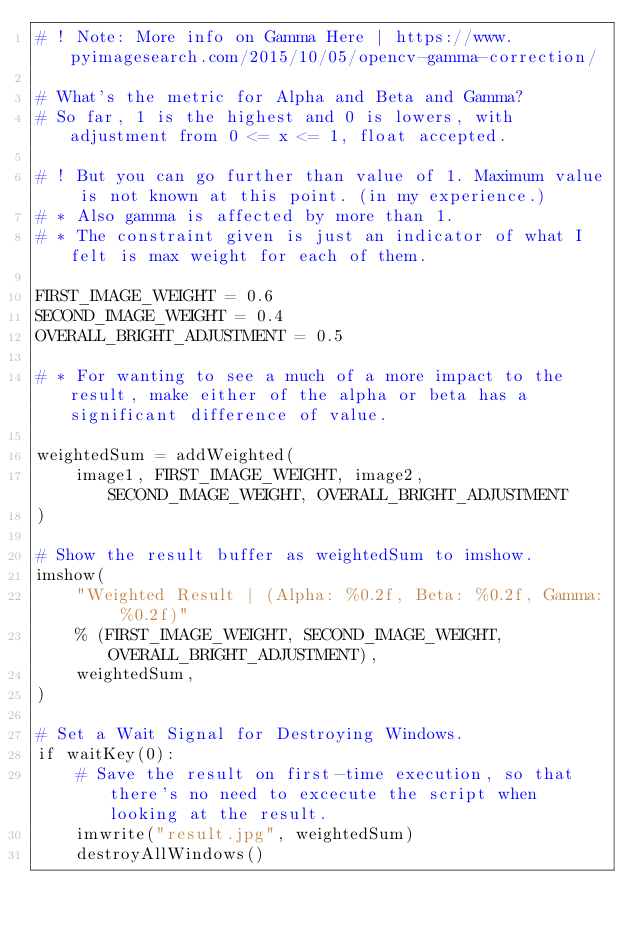<code> <loc_0><loc_0><loc_500><loc_500><_Python_># ! Note: More info on Gamma Here | https://www.pyimagesearch.com/2015/10/05/opencv-gamma-correction/

# What's the metric for Alpha and Beta and Gamma?
# So far, 1 is the highest and 0 is lowers, with adjustment from 0 <= x <= 1, float accepted.

# ! But you can go further than value of 1. Maximum value is not known at this point. (in my experience.)
# * Also gamma is affected by more than 1.
# * The constraint given is just an indicator of what I felt is max weight for each of them.

FIRST_IMAGE_WEIGHT = 0.6
SECOND_IMAGE_WEIGHT = 0.4
OVERALL_BRIGHT_ADJUSTMENT = 0.5

# * For wanting to see a much of a more impact to the result, make either of the alpha or beta has a significant difference of value.

weightedSum = addWeighted(
    image1, FIRST_IMAGE_WEIGHT, image2, SECOND_IMAGE_WEIGHT, OVERALL_BRIGHT_ADJUSTMENT
)

# Show the result buffer as weightedSum to imshow.
imshow(
    "Weighted Result | (Alpha: %0.2f, Beta: %0.2f, Gamma: %0.2f)"
    % (FIRST_IMAGE_WEIGHT, SECOND_IMAGE_WEIGHT, OVERALL_BRIGHT_ADJUSTMENT),
    weightedSum,
)

# Set a Wait Signal for Destroying Windows.
if waitKey(0):
    # Save the result on first-time execution, so that there's no need to excecute the script when looking at the result.
    imwrite("result.jpg", weightedSum)
    destroyAllWindows()
</code> 